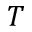Convert formula to latex. <formula><loc_0><loc_0><loc_500><loc_500>T</formula> 